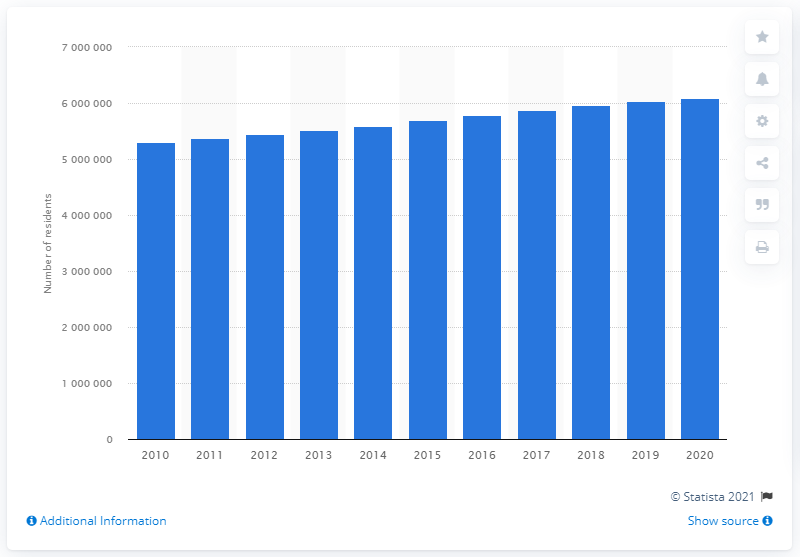Outline some significant characteristics in this image. In 2020, the population of the Atlanta-Sandy Springs-Alpharetta metropolitan area was approximately 6.08 million people. In the year 2020, the population of the Atlanta-Sandy Springs-Alpharetta metropolitan area was approximately 602,7231. The population of the Atlanta-Sandy Springs-Alpharetta metropolitan area in the previous year was 596,1394. 